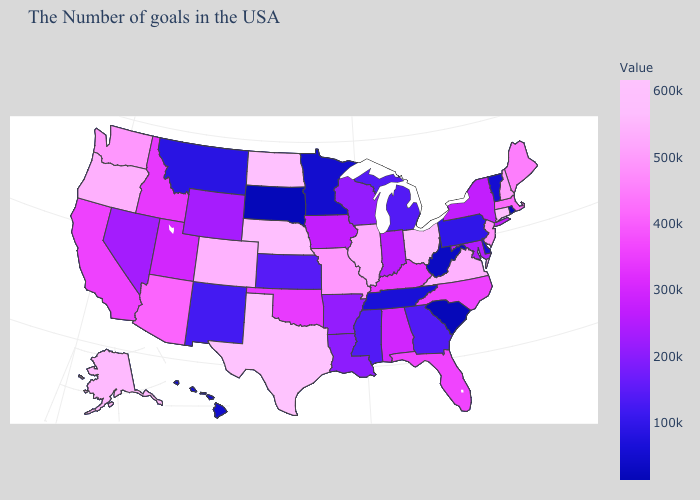Among the states that border Pennsylvania , does West Virginia have the lowest value?
Keep it brief. Yes. Among the states that border New Hampshire , which have the highest value?
Concise answer only. Maine. Among the states that border West Virginia , which have the lowest value?
Answer briefly. Pennsylvania. Does Alaska have the highest value in the West?
Concise answer only. Yes. Among the states that border Oklahoma , does Texas have the highest value?
Give a very brief answer. Yes. Among the states that border Nevada , does Idaho have the lowest value?
Quick response, please. No. 